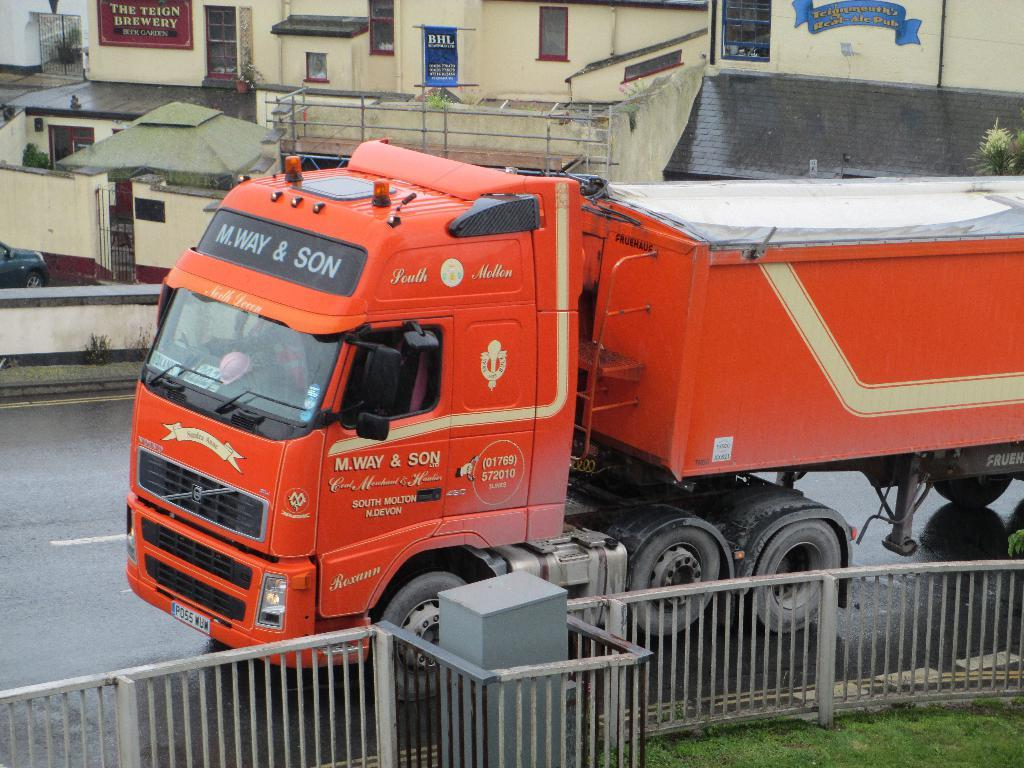What type of vehicle is on the road in the image? There is a truck on the road in the image. What can be seen alongside the road in the image? There is railing visible in the image. What type of surface is visible near the truck? There is a grass surface in the image. What can be seen on the other side of the road in the image? There are buildings with windows on the other side of the road in the image. How many plates are stacked on the truck in the image? There are no plates visible in the image; it only shows a truck on the road. 